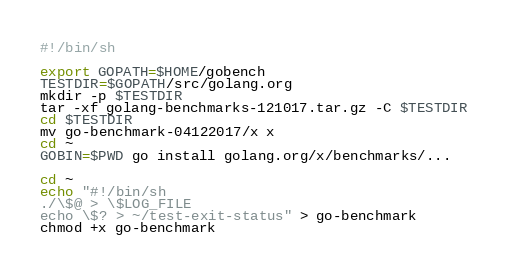Convert code to text. <code><loc_0><loc_0><loc_500><loc_500><_Bash_>#!/bin/sh

export GOPATH=$HOME/gobench
TESTDIR=$GOPATH/src/golang.org
mkdir -p $TESTDIR
tar -xf golang-benchmarks-121017.tar.gz -C $TESTDIR
cd $TESTDIR
mv go-benchmark-04122017/x x
cd ~
GOBIN=$PWD go install golang.org/x/benchmarks/...

cd ~
echo "#!/bin/sh
./\$@ > \$LOG_FILE
echo \$? > ~/test-exit-status" > go-benchmark
chmod +x go-benchmark
</code> 